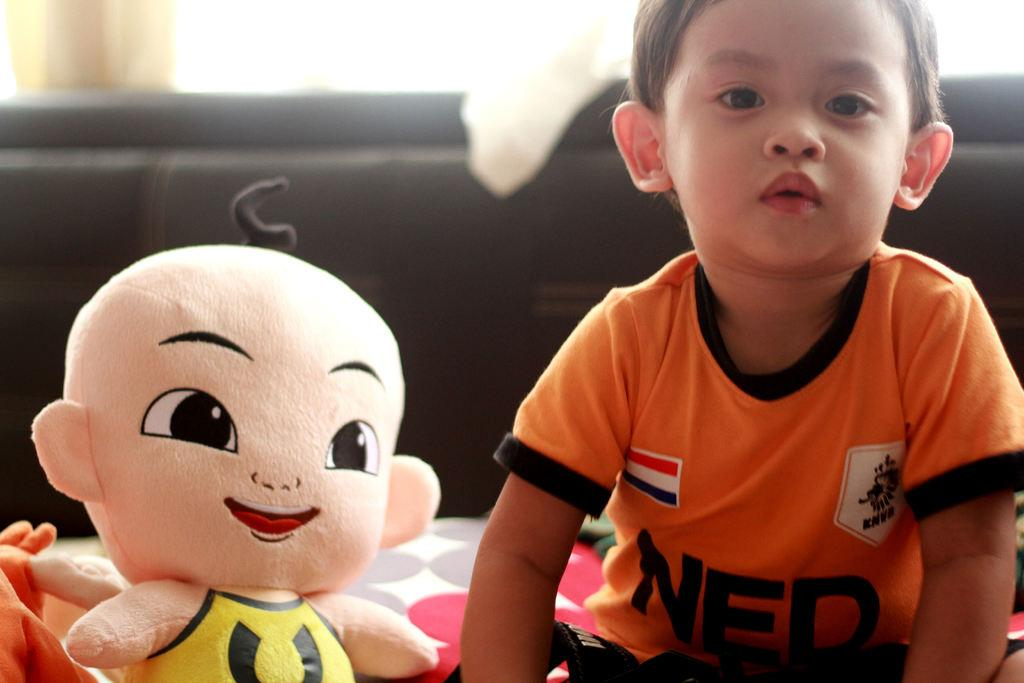What is the main subject in the foreground of the image? There is a boy in the foreground of the image. What is the boy doing in the image? The boy is sitting. What object is beside the boy? There is a toy beside the boy. What can be seen in the background of the image? There is a bed and a window in the background of the image. What type of window treatment is present in the image? There are curtains associated with the window. What type of metal is visible in the image? There is no metal visible in the image. Can you describe the picture hanging on the wall in the image? There is no picture hanging on the wall in the image. How many dogs are present in the image? There are no dogs present in the image. 